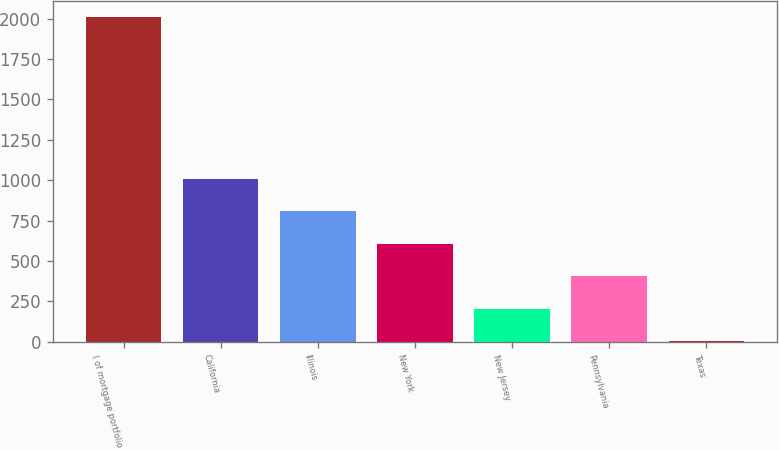Convert chart. <chart><loc_0><loc_0><loc_500><loc_500><bar_chart><fcel>( of mortgage portfolio<fcel>California<fcel>Illinois<fcel>New York<fcel>New Jersey<fcel>Pennsylvania<fcel>Texas<nl><fcel>2009<fcel>1007<fcel>806.6<fcel>606.2<fcel>205.4<fcel>405.8<fcel>5<nl></chart> 